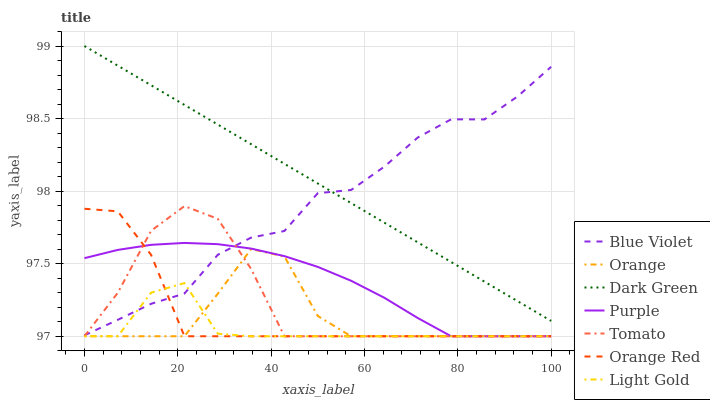Does Purple have the minimum area under the curve?
Answer yes or no. No. Does Purple have the maximum area under the curve?
Answer yes or no. No. Is Purple the smoothest?
Answer yes or no. No. Is Purple the roughest?
Answer yes or no. No. Does Blue Violet have the lowest value?
Answer yes or no. No. Does Purple have the highest value?
Answer yes or no. No. Is Orange Red less than Dark Green?
Answer yes or no. Yes. Is Dark Green greater than Orange Red?
Answer yes or no. Yes. Does Orange Red intersect Dark Green?
Answer yes or no. No. 